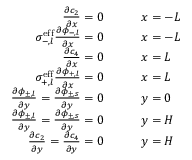Convert formula to latex. <formula><loc_0><loc_0><loc_500><loc_500>\begin{array} { r l } { \frac { \partial c _ { 2 } } { \partial x } = 0 \quad } & { x = - L } \\ { \sigma _ { - , l } ^ { e f f } \frac { \partial \phi _ { - , l } } { \partial x } = 0 \quad } & { x = - L } \\ { \frac { \partial c _ { 4 } } { \partial x } = 0 \quad } & { x = L } \\ { \sigma _ { + , l } ^ { e f f } \frac { \partial \phi _ { + , l } } { \partial x } = 0 \quad } & { x = L } \\ { \frac { \partial \phi _ { \pm , l } } { \partial y } = \frac { \partial \phi _ { \pm , s } } { \partial y } = 0 \quad } & { y = 0 } \\ { \frac { \partial \phi _ { \pm , l } } { \partial y } = \frac { \partial \phi _ { \pm , s } } { \partial y } = 0 \quad } & { y = H } \\ { \frac { \partial c _ { 2 } } { \partial y } = \frac { \partial c _ { 4 } } { \partial y } = 0 \quad } & { y = H } \end{array}</formula> 